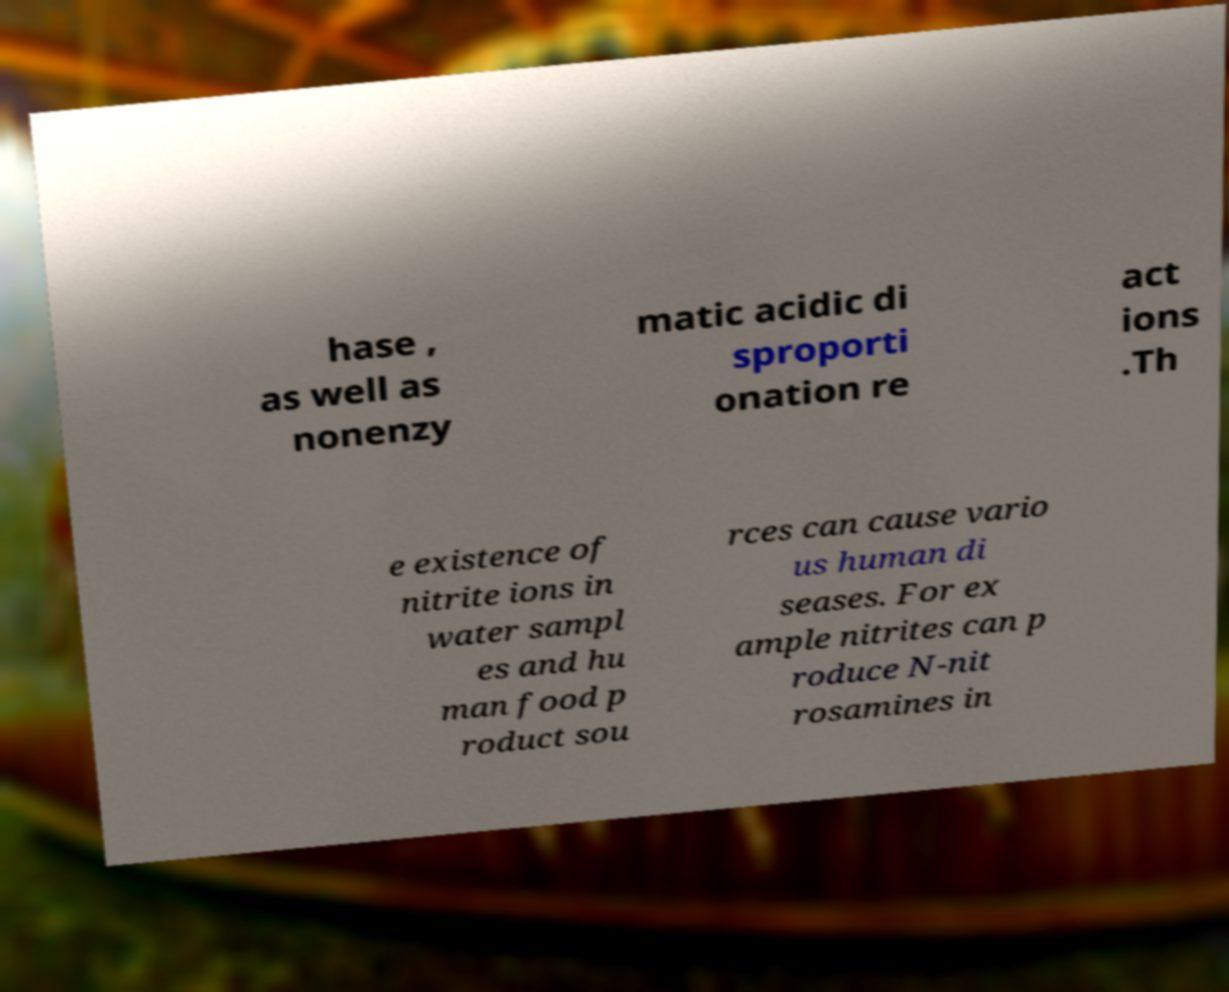Could you assist in decoding the text presented in this image and type it out clearly? hase , as well as nonenzy matic acidic di sproporti onation re act ions .Th e existence of nitrite ions in water sampl es and hu man food p roduct sou rces can cause vario us human di seases. For ex ample nitrites can p roduce N-nit rosamines in 